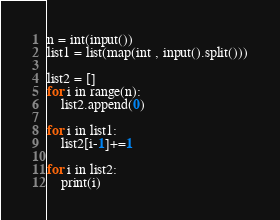Convert code to text. <code><loc_0><loc_0><loc_500><loc_500><_Python_>n = int(input())
list1 = list(map(int , input().split()))

list2 = []
for i in range(n):
    list2.append(0)

for i in list1:
    list2[i-1]+=1

for i in list2:
    print(i)</code> 